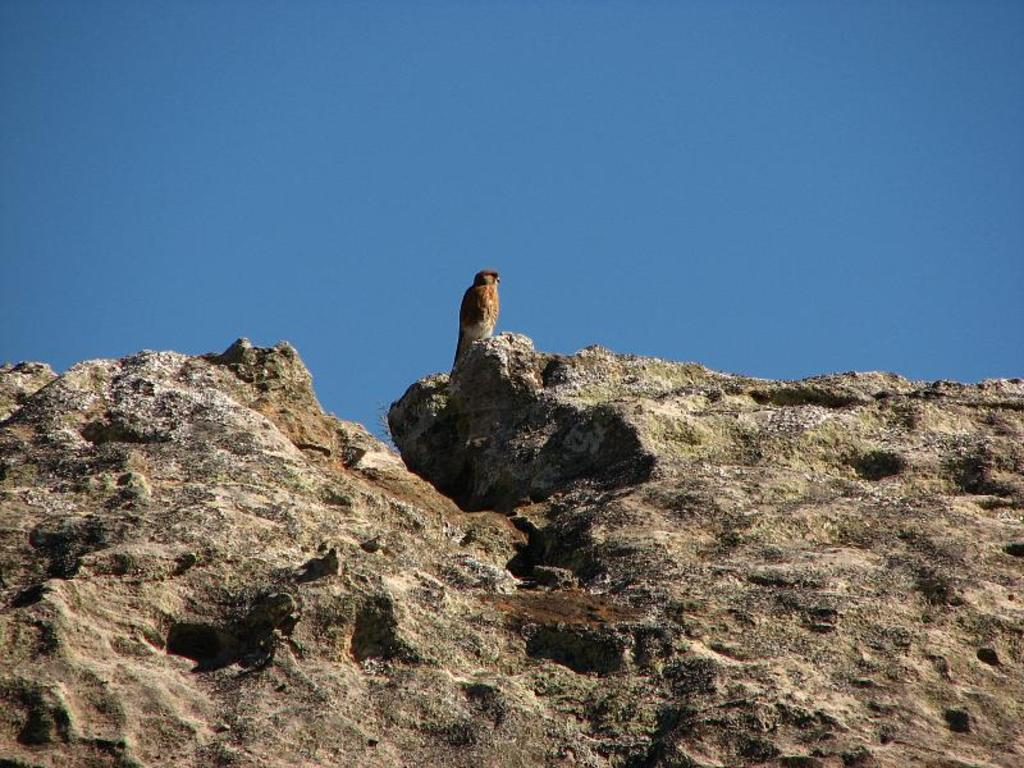What type of animal is in the image? There is a bird in the image. Where is the bird located? The bird is on a rock. What can be seen in the background of the image? There is sky visible in the background of the image. What type of canvas is the pig using to paint the frog in the image? There is no canvas, pig, or frog present in the image; it features a bird on a rock with sky visible in the background. 